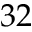<formula> <loc_0><loc_0><loc_500><loc_500>3 2</formula> 